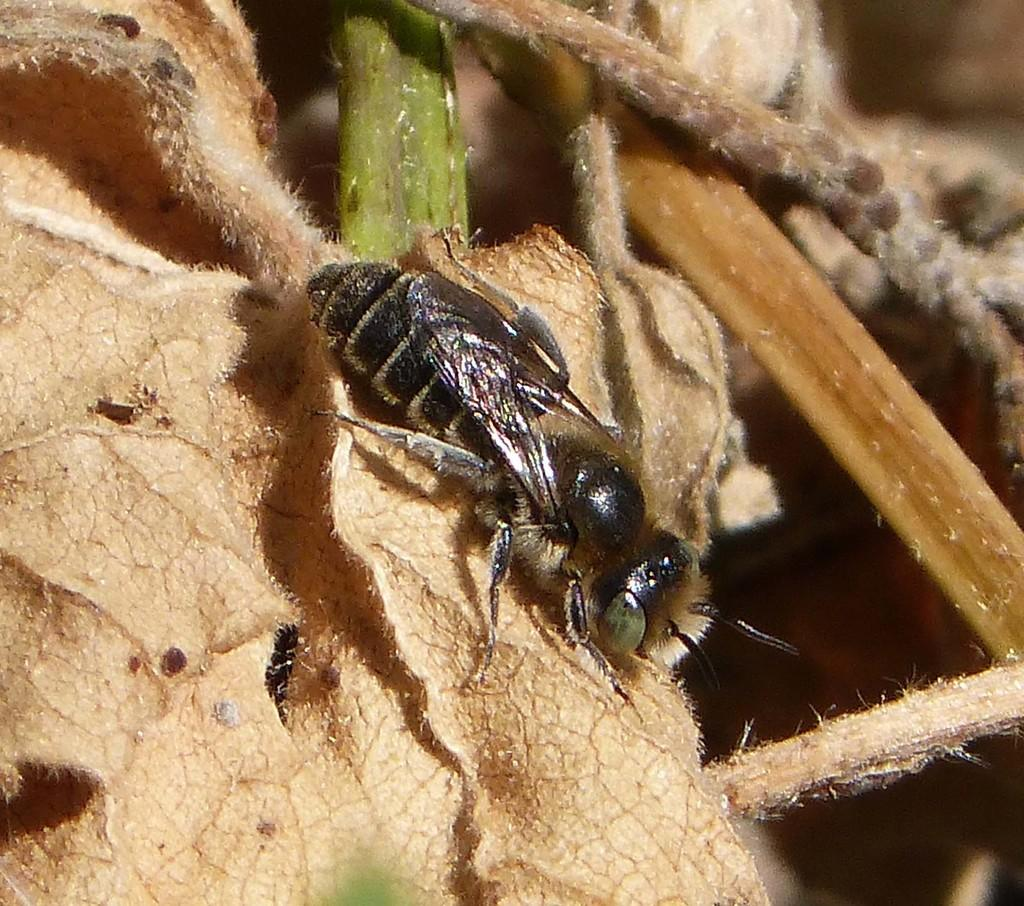What type of creature is present in the image? There is an insect in the image. Where is the insect located? The insect is on a plant. What type of coil can be seen wrapped around the insect in the image? There is no coil present in the image, and the insect is not wrapped around anything. Can you tell me how many snakes are visible in the image? There are no snakes present in the image; it features an insect on a plant. What is the mother of the insect doing in the image? There is no mother of the insect present in the image, as insects do not have mothers in the same way mammals do. 